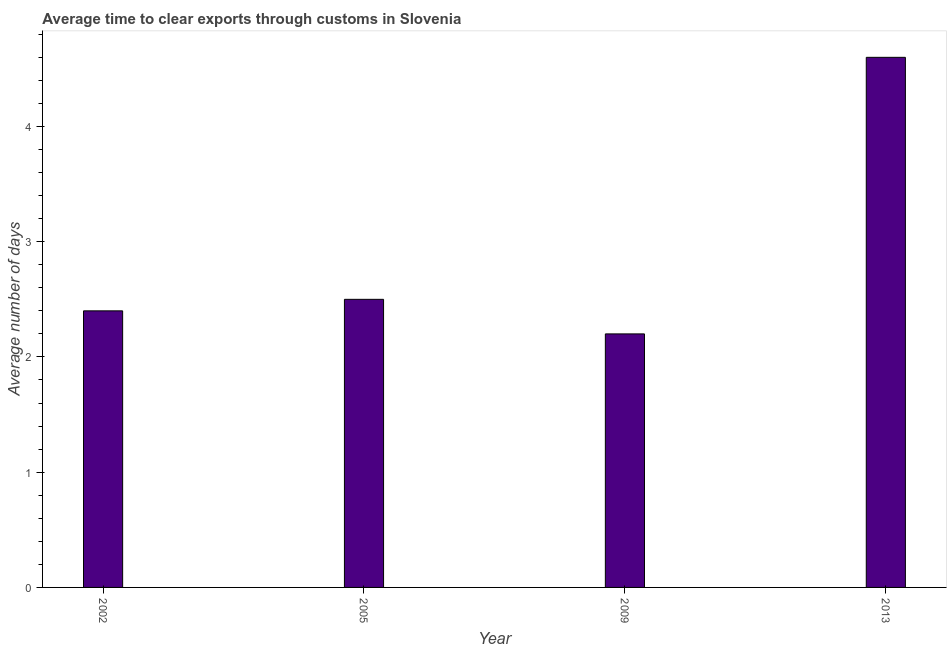What is the title of the graph?
Provide a short and direct response. Average time to clear exports through customs in Slovenia. What is the label or title of the X-axis?
Provide a short and direct response. Year. What is the label or title of the Y-axis?
Offer a terse response. Average number of days. In which year was the time to clear exports through customs maximum?
Provide a succinct answer. 2013. What is the difference between the time to clear exports through customs in 2002 and 2005?
Provide a short and direct response. -0.1. What is the average time to clear exports through customs per year?
Offer a terse response. 2.92. What is the median time to clear exports through customs?
Offer a terse response. 2.45. In how many years, is the time to clear exports through customs greater than 3.8 days?
Ensure brevity in your answer.  1. What is the ratio of the time to clear exports through customs in 2002 to that in 2013?
Your response must be concise. 0.52. Is the time to clear exports through customs in 2005 less than that in 2009?
Offer a very short reply. No. What is the difference between the highest and the lowest time to clear exports through customs?
Keep it short and to the point. 2.4. In how many years, is the time to clear exports through customs greater than the average time to clear exports through customs taken over all years?
Keep it short and to the point. 1. How many bars are there?
Offer a very short reply. 4. How many years are there in the graph?
Provide a succinct answer. 4. What is the difference between two consecutive major ticks on the Y-axis?
Give a very brief answer. 1. Are the values on the major ticks of Y-axis written in scientific E-notation?
Your answer should be compact. No. What is the difference between the Average number of days in 2002 and 2009?
Your answer should be very brief. 0.2. What is the difference between the Average number of days in 2002 and 2013?
Ensure brevity in your answer.  -2.2. What is the difference between the Average number of days in 2005 and 2009?
Your answer should be very brief. 0.3. What is the difference between the Average number of days in 2009 and 2013?
Give a very brief answer. -2.4. What is the ratio of the Average number of days in 2002 to that in 2009?
Give a very brief answer. 1.09. What is the ratio of the Average number of days in 2002 to that in 2013?
Your response must be concise. 0.52. What is the ratio of the Average number of days in 2005 to that in 2009?
Provide a short and direct response. 1.14. What is the ratio of the Average number of days in 2005 to that in 2013?
Make the answer very short. 0.54. What is the ratio of the Average number of days in 2009 to that in 2013?
Your answer should be very brief. 0.48. 